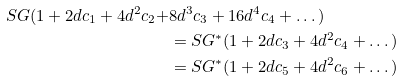<formula> <loc_0><loc_0><loc_500><loc_500>S G ( 1 + 2 d c _ { 1 } + 4 d ^ { 2 } c _ { 2 } + & 8 d ^ { 3 } c _ { 3 } + 1 6 d ^ { 4 } c _ { 4 } + \dots ) \\ & = S G ^ { * } ( 1 + 2 d c _ { 3 } + 4 d ^ { 2 } c _ { 4 } + \dots ) \\ & = S G ^ { * } ( 1 + 2 d c _ { 5 } + 4 d ^ { 2 } c _ { 6 } + \dots )</formula> 